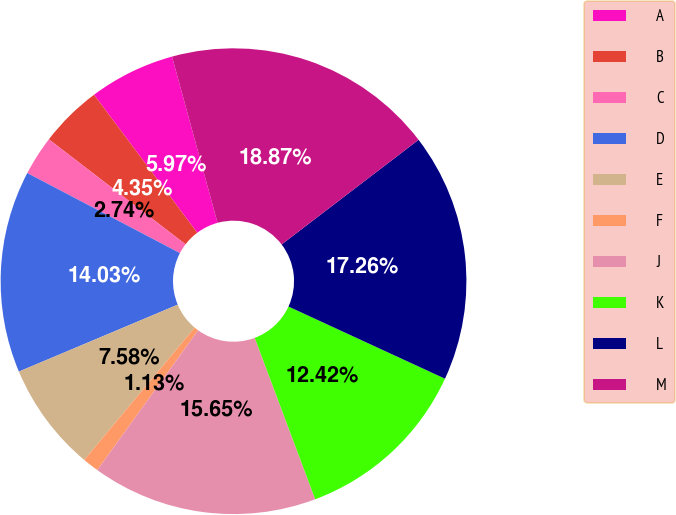<chart> <loc_0><loc_0><loc_500><loc_500><pie_chart><fcel>A<fcel>B<fcel>C<fcel>D<fcel>E<fcel>F<fcel>J<fcel>K<fcel>L<fcel>M<nl><fcel>5.97%<fcel>4.35%<fcel>2.74%<fcel>14.03%<fcel>7.58%<fcel>1.13%<fcel>15.65%<fcel>12.42%<fcel>17.26%<fcel>18.87%<nl></chart> 